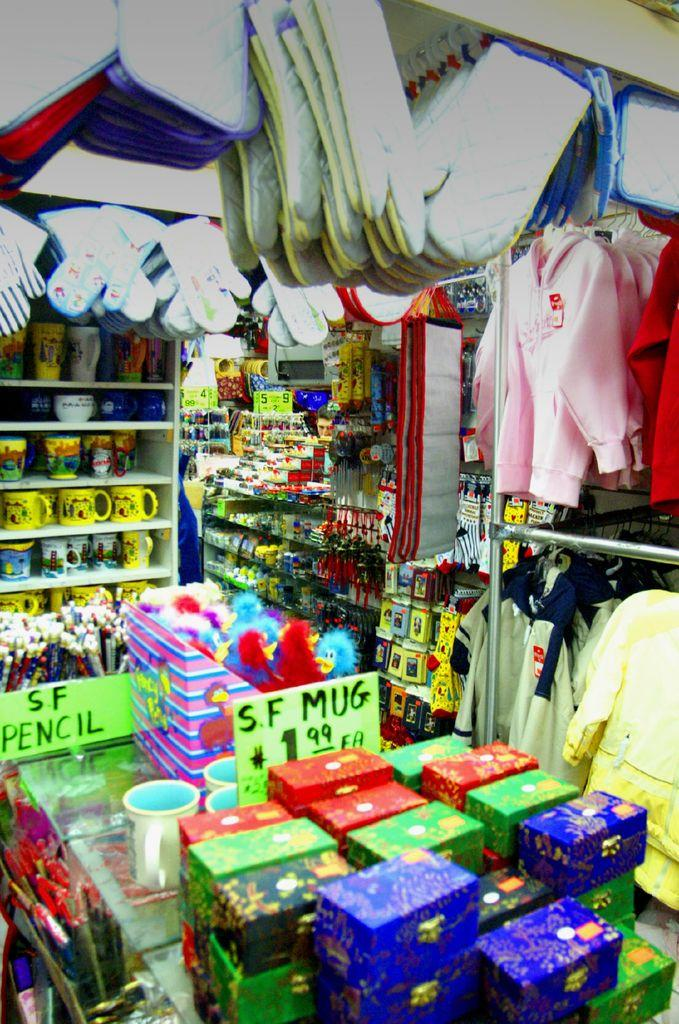<image>
Create a compact narrative representing the image presented. A store selling a variety of products including S F Mugs for $1.99 